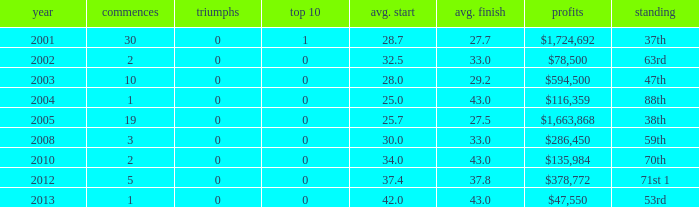How many starts for an average finish greater than 43? None. 